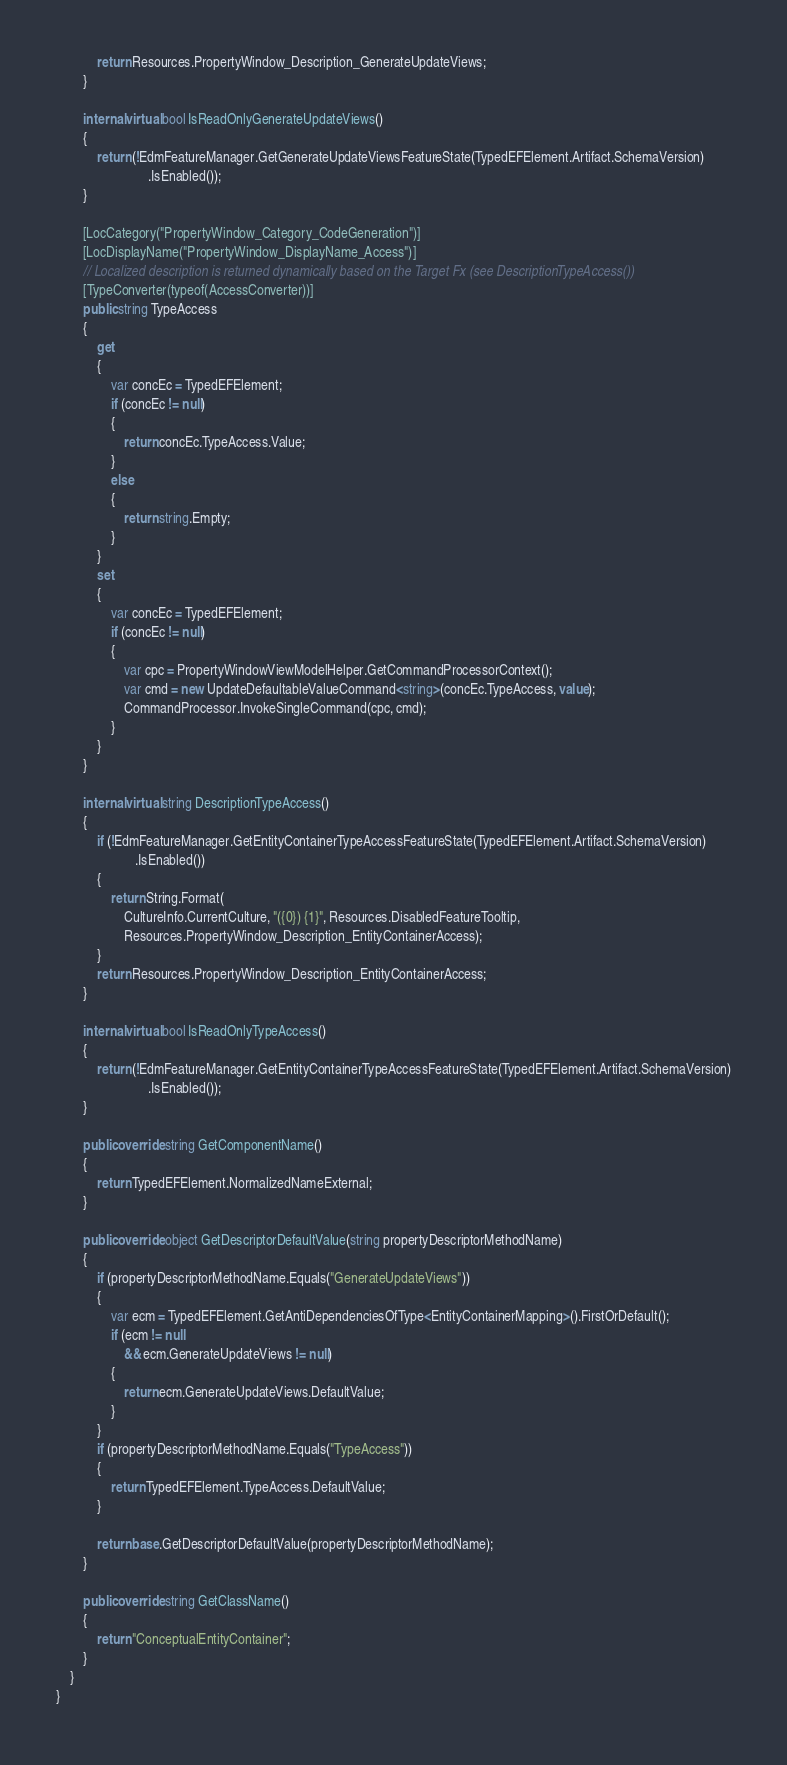<code> <loc_0><loc_0><loc_500><loc_500><_C#_>            return Resources.PropertyWindow_Description_GenerateUpdateViews;
        }

        internal virtual bool IsReadOnlyGenerateUpdateViews()
        {
            return (!EdmFeatureManager.GetGenerateUpdateViewsFeatureState(TypedEFElement.Artifact.SchemaVersion)
                           .IsEnabled());
        }

        [LocCategory("PropertyWindow_Category_CodeGeneration")]
        [LocDisplayName("PropertyWindow_DisplayName_Access")]
        // Localized description is returned dynamically based on the Target Fx (see DescriptionTypeAccess())
        [TypeConverter(typeof(AccessConverter))]
        public string TypeAccess
        {
            get
            {
                var concEc = TypedEFElement;
                if (concEc != null)
                {
                    return concEc.TypeAccess.Value;
                }
                else
                {
                    return string.Empty;
                }
            }
            set
            {
                var concEc = TypedEFElement;
                if (concEc != null)
                {
                    var cpc = PropertyWindowViewModelHelper.GetCommandProcessorContext();
                    var cmd = new UpdateDefaultableValueCommand<string>(concEc.TypeAccess, value);
                    CommandProcessor.InvokeSingleCommand(cpc, cmd);
                }
            }
        }

        internal virtual string DescriptionTypeAccess()
        {
            if (!EdmFeatureManager.GetEntityContainerTypeAccessFeatureState(TypedEFElement.Artifact.SchemaVersion)
                       .IsEnabled())
            {
                return String.Format(
                    CultureInfo.CurrentCulture, "({0}) {1}", Resources.DisabledFeatureTooltip,
                    Resources.PropertyWindow_Description_EntityContainerAccess);
            }
            return Resources.PropertyWindow_Description_EntityContainerAccess;
        }

        internal virtual bool IsReadOnlyTypeAccess()
        {
            return (!EdmFeatureManager.GetEntityContainerTypeAccessFeatureState(TypedEFElement.Artifact.SchemaVersion)
                           .IsEnabled());
        }

        public override string GetComponentName()
        {
            return TypedEFElement.NormalizedNameExternal;
        }

        public override object GetDescriptorDefaultValue(string propertyDescriptorMethodName)
        {
            if (propertyDescriptorMethodName.Equals("GenerateUpdateViews"))
            {
                var ecm = TypedEFElement.GetAntiDependenciesOfType<EntityContainerMapping>().FirstOrDefault();
                if (ecm != null
                    && ecm.GenerateUpdateViews != null)
                {
                    return ecm.GenerateUpdateViews.DefaultValue;
                }
            }
            if (propertyDescriptorMethodName.Equals("TypeAccess"))
            {
                return TypedEFElement.TypeAccess.DefaultValue;
            }

            return base.GetDescriptorDefaultValue(propertyDescriptorMethodName);
        }

        public override string GetClassName()
        {
            return "ConceptualEntityContainer";
        }
    }
}
</code> 